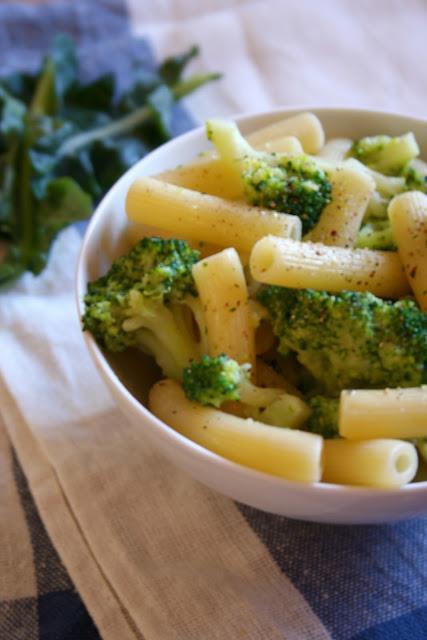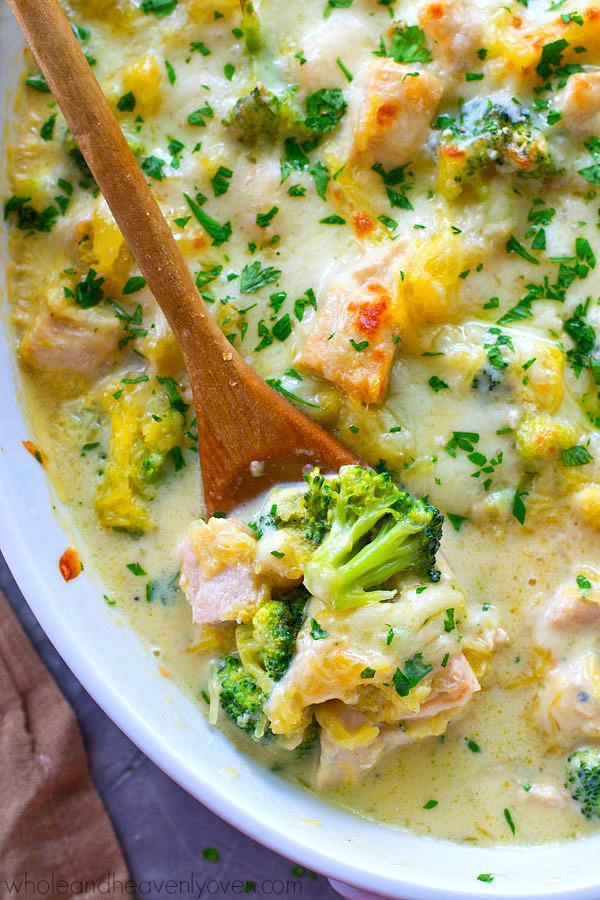The first image is the image on the left, the second image is the image on the right. Considering the images on both sides, is "A metalic spoon is in one of the food." valid? Answer yes or no. No. The first image is the image on the left, the second image is the image on the right. Evaluate the accuracy of this statement regarding the images: "There is a serving utensil in the dish on the right.". Is it true? Answer yes or no. Yes. 